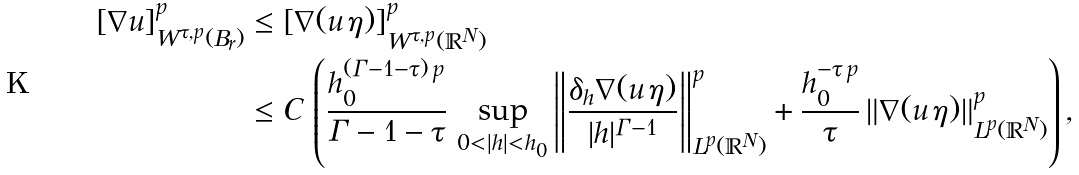Convert formula to latex. <formula><loc_0><loc_0><loc_500><loc_500>[ \nabla u ] ^ { p } _ { W ^ { \tau , p } ( B _ { r } ) } & \leq [ \nabla ( u \, \eta ) ] ^ { p } _ { W ^ { \tau , p } ( \mathbb { R } ^ { N } ) } \\ & \leq C \, \left ( \frac { h _ { 0 } ^ { ( \Gamma - 1 - \tau ) \, p } } { \Gamma - 1 - \tau } \, \sup _ { 0 < | h | < h _ { 0 } } \left \| \frac { \delta _ { h } \nabla ( u \, \eta ) } { | h | ^ { \Gamma - 1 } } \right \| _ { L ^ { p } ( \mathbb { R } ^ { N } ) } ^ { p } + \frac { h _ { 0 } ^ { - \tau \, p } } { \tau } \, \| \nabla ( u \, \eta ) \| ^ { p } _ { L ^ { p } ( \mathbb { R } ^ { N } ) } \right ) ,</formula> 